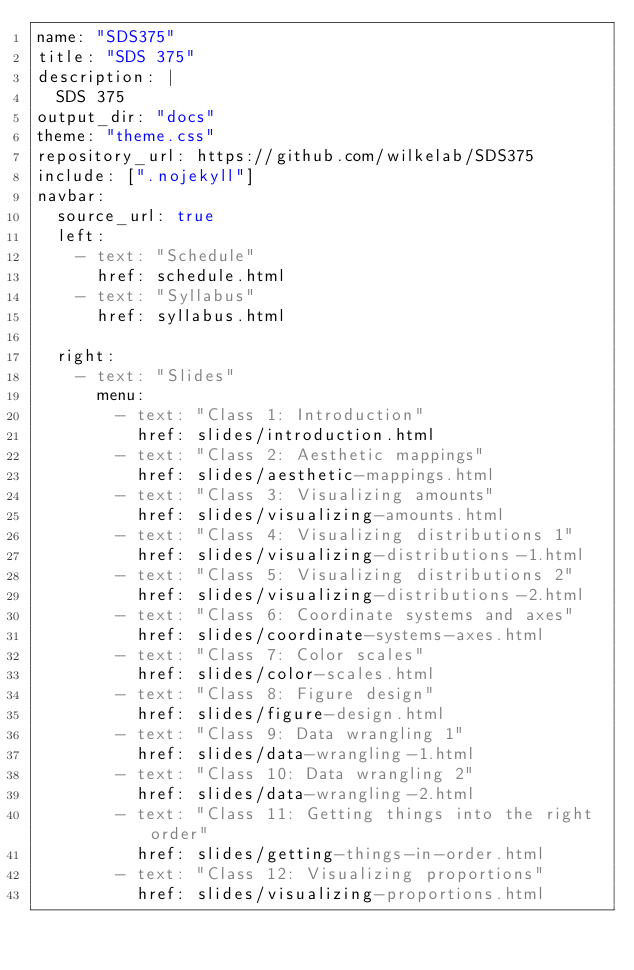<code> <loc_0><loc_0><loc_500><loc_500><_YAML_>name: "SDS375"
title: "SDS 375"
description: |
  SDS 375
output_dir: "docs"
theme: "theme.css"
repository_url: https://github.com/wilkelab/SDS375
include: [".nojekyll"]
navbar:
  source_url: true
  left:
    - text: "Schedule"
      href: schedule.html
    - text: "Syllabus"
      href: syllabus.html

  right:
    - text: "Slides"
      menu:
        - text: "Class 1: Introduction"
          href: slides/introduction.html
        - text: "Class 2: Aesthetic mappings"
          href: slides/aesthetic-mappings.html
        - text: "Class 3: Visualizing amounts"
          href: slides/visualizing-amounts.html
        - text: "Class 4: Visualizing distributions 1"
          href: slides/visualizing-distributions-1.html
        - text: "Class 5: Visualizing distributions 2"
          href: slides/visualizing-distributions-2.html
        - text: "Class 6: Coordinate systems and axes"
          href: slides/coordinate-systems-axes.html
        - text: "Class 7: Color scales"
          href: slides/color-scales.html
        - text: "Class 8: Figure design"
          href: slides/figure-design.html
        - text: "Class 9: Data wrangling 1"
          href: slides/data-wrangling-1.html
        - text: "Class 10: Data wrangling 2"
          href: slides/data-wrangling-2.html
        - text: "Class 11: Getting things into the right order"
          href: slides/getting-things-in-order.html
        - text: "Class 12: Visualizing proportions"
          href: slides/visualizing-proportions.html</code> 